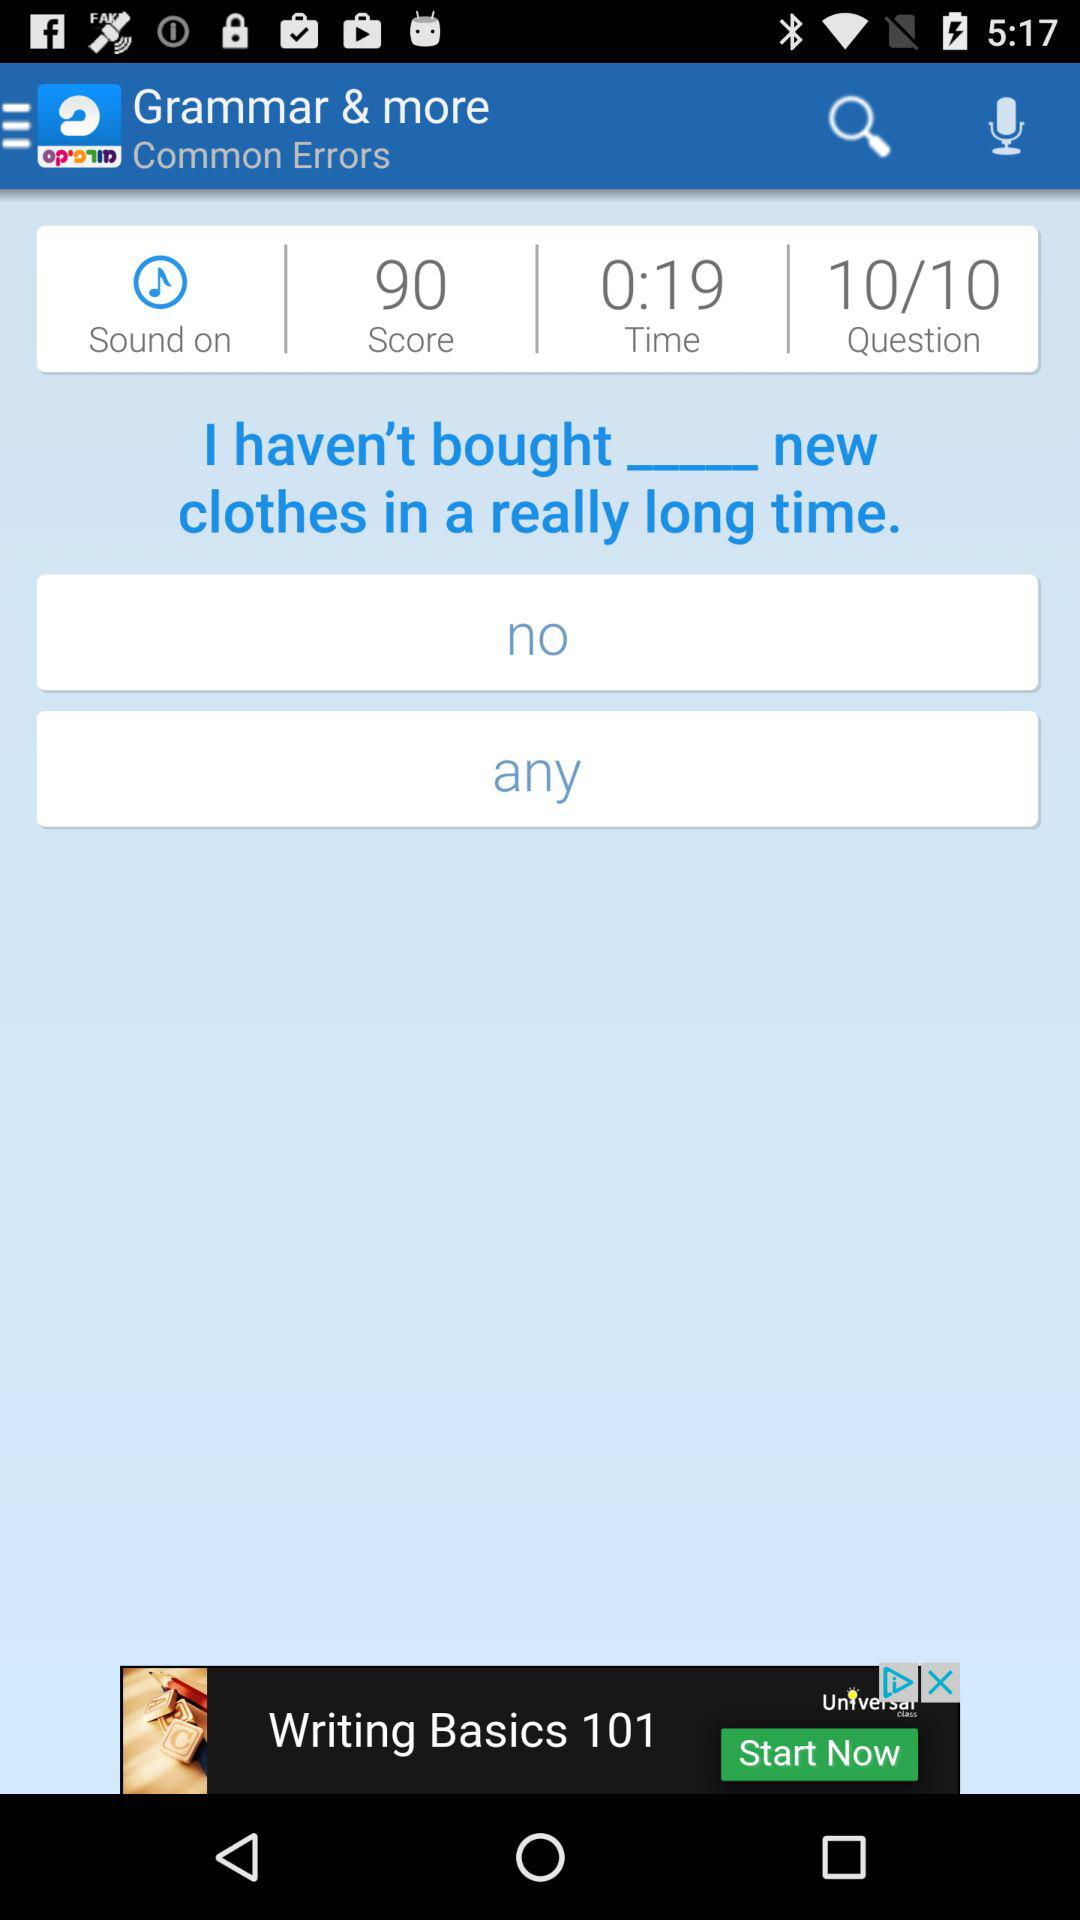How much is the score? The score is 90. 